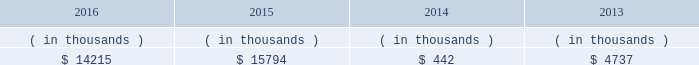Entergy new orleans , inc .
And subsidiaries management 2019s financial discussion and analysis entergy new orleans 2019s receivables from the money pool were as follows as of december 31 for each of the following years. .
See note 4 to the financial statements for a description of the money pool .
Entergy new orleans has a credit facility in the amount of $ 25 million scheduled to expire in november 2018 .
The credit facility allows entergy new orleans to issue letters of credit against $ 10 million of the borrowing capacity of the facility .
As of december 31 , 2016 , there were no cash borrowings and a $ 0.8 million letter of credit was outstanding under the facility .
In addition , entergy new orleans is a party to an uncommitted letter of credit facility as a means to post collateral to support its obligations under miso .
As of december 31 , 2016 , a $ 6.2 million letter of credit was outstanding under entergy new orleans 2019s letter of credit facility .
See note 4 to the financial statements for additional discussion of the credit facilities .
Entergy new orleans obtained authorization from the ferc through october 2017 for short-term borrowings not to exceed an aggregate amount of $ 100 million at any time outstanding .
See note 4 to the financial statements for further discussion of entergy new orleans 2019s short-term borrowing limits .
The long-term securities issuances of entergy new orleans are limited to amounts authorized by the city council , and the current authorization extends through june 2018 .
State and local rate regulation the rates that entergy new orleans charges for electricity and natural gas significantly influence its financial position , results of operations , and liquidity .
Entergy new orleans is regulated and the rates charged to its customers are determined in regulatory proceedings .
A governmental agency , the city council , is primarily responsible for approval of the rates charged to customers .
Retail rates see 201calgiers asset transfer 201d below for discussion of the transfer from entergy louisiana to entergy new orleans of certain assets that serve algiers customers .
In march 2013 , entergy louisiana filed a rate case for the algiers area , which is in new orleans and is regulated by the city council .
Entergy louisiana requested a rate increase of $ 13 million over three years , including a 10.4% ( 10.4 % ) return on common equity and a formula rate plan mechanism identical to its lpsc request .
In january 2014 the city council advisors filed direct testimony recommending a rate increase of $ 5.56 million over three years , including an 8.13% ( 8.13 % ) return on common equity .
In june 2014 the city council unanimously approved a settlement that includes the following : 2022 a $ 9.3 million base rate revenue increase to be phased in on a levelized basis over four years ; 2022 recovery of an additional $ 853 thousand annually through a miso recovery rider ; and 2022 the adoption of a four-year formula rate plan requiring the filing of annual evaluation reports in may of each year , commencing may 2015 , with resulting rates being implemented in october of each year .
The formula rate plan includes a midpoint target authorized return on common equity of 9.95% ( 9.95 % ) with a +/- 40 basis point bandwidth .
The rate increase was effective with bills rendered on and after the first billing cycle of july 2014 .
Additional compliance filings were made with the city council in october 2014 for approval of the form of certain rate riders , including among others , a ninemile 6 non-fuel cost recovery interim rider , allowing for contemporaneous recovery of capacity .
What is the percentage change in entergy new orleans 2019s receivables from the money pool from 2015 to 2016? 
Computations: ((14215 - 15794) / 15794)
Answer: -0.09997. 